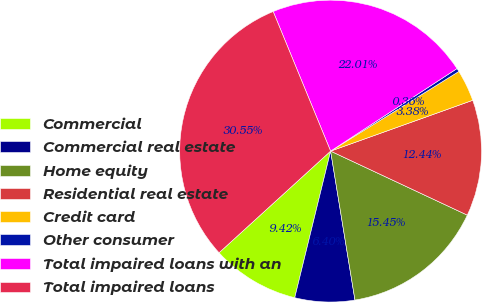Convert chart to OTSL. <chart><loc_0><loc_0><loc_500><loc_500><pie_chart><fcel>Commercial<fcel>Commercial real estate<fcel>Home equity<fcel>Residential real estate<fcel>Credit card<fcel>Other consumer<fcel>Total impaired loans with an<fcel>Total impaired loans<nl><fcel>9.42%<fcel>6.4%<fcel>15.45%<fcel>12.44%<fcel>3.38%<fcel>0.36%<fcel>22.01%<fcel>30.55%<nl></chart> 